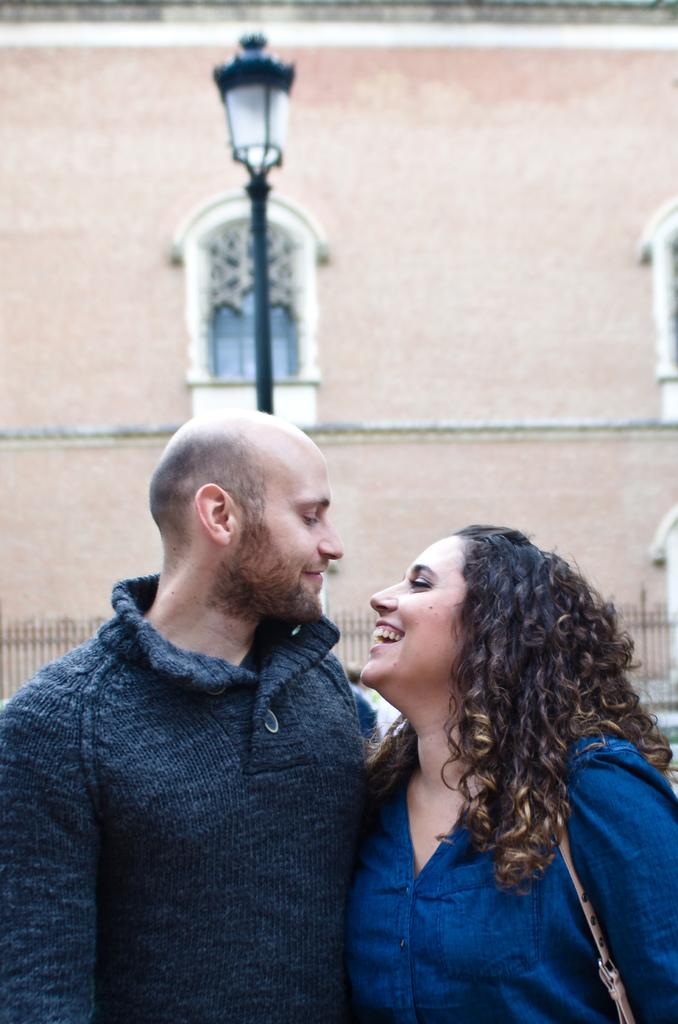Who are the people in the image? There is a man and a girl in the image. What is the girl doing in the image? The girl is laughing in the image. What is the girl wearing in the image? The girl is wearing a blue dress in the image. What can be seen in the background of the image? There is a lamp and a building in the background of the image. What type of cracker is the girl holding in the image? There is no cracker present in the image. What kind of trouble is the man causing in the image? There is no indication of trouble or any negative actions in the image. 